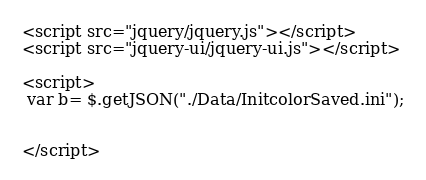Convert code to text. <code><loc_0><loc_0><loc_500><loc_500><_PHP_><script src="jquery/jquery.js"></script>
<script src="jquery-ui/jquery-ui.js"></script>

<script>
 var b=	$.getJSON("./Data/InitcolorSaved.ini");


</script>
</code> 